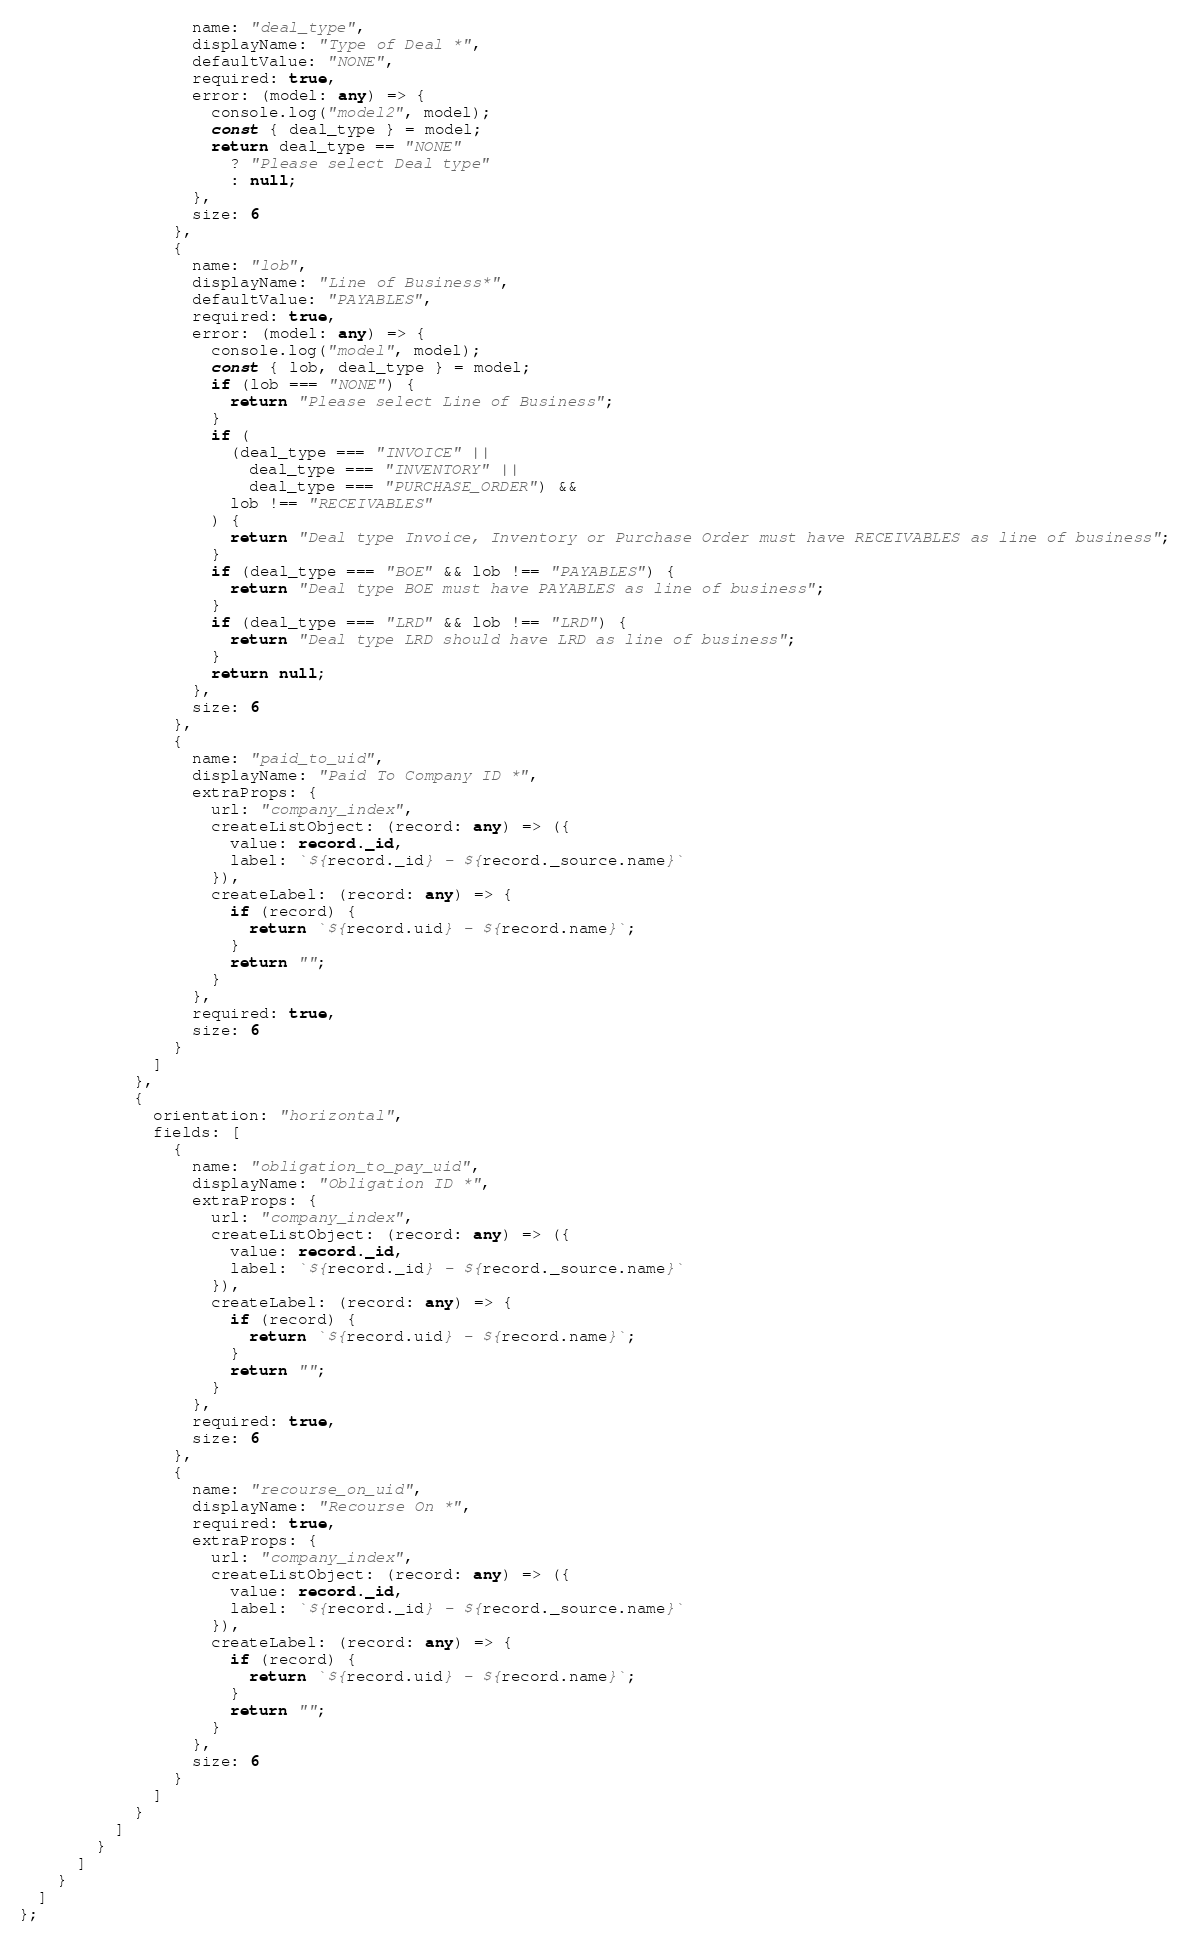Convert code to text. <code><loc_0><loc_0><loc_500><loc_500><_TypeScript_>                  name: "deal_type",
                  displayName: "Type of Deal *",
                  defaultValue: "NONE",
                  required: true,
                  error: (model: any) => {
                    console.log("model2", model);
                    const { deal_type } = model;
                    return deal_type == "NONE"
                      ? "Please select Deal type"
                      : null;
                  },
                  size: 6
                },
                {
                  name: "lob",
                  displayName: "Line of Business*",
                  defaultValue: "PAYABLES",
                  required: true,
                  error: (model: any) => {
                    console.log("model", model);
                    const { lob, deal_type } = model;
                    if (lob === "NONE") {
                      return "Please select Line of Business";
                    }
                    if (
                      (deal_type === "INVOICE" ||
                        deal_type === "INVENTORY" ||
                        deal_type === "PURCHASE_ORDER") &&
                      lob !== "RECEIVABLES"
                    ) {
                      return "Deal type Invoice, Inventory or Purchase Order must have RECEIVABLES as line of business";
                    }
                    if (deal_type === "BOE" && lob !== "PAYABLES") {
                      return "Deal type BOE must have PAYABLES as line of business";
                    }
                    if (deal_type === "LRD" && lob !== "LRD") {
                      return "Deal type LRD should have LRD as line of business";
                    }
                    return null;
                  },
                  size: 6
                },
                {
                  name: "paid_to_uid",
                  displayName: "Paid To Company ID *",
                  extraProps: {
                    url: "company_index",
                    createListObject: (record: any) => ({
                      value: record._id,
                      label: `${record._id} - ${record._source.name}`
                    }),
                    createLabel: (record: any) => {
                      if (record) {
                        return `${record.uid} - ${record.name}`;
                      }
                      return "";
                    }
                  },
                  required: true,
                  size: 6
                }
              ]
            },
            {
              orientation: "horizontal",
              fields: [
                {
                  name: "obligation_to_pay_uid",
                  displayName: "Obligation ID *",
                  extraProps: {
                    url: "company_index",
                    createListObject: (record: any) => ({
                      value: record._id,
                      label: `${record._id} - ${record._source.name}`
                    }),
                    createLabel: (record: any) => {
                      if (record) {
                        return `${record.uid} - ${record.name}`;
                      }
                      return "";
                    }
                  },
                  required: true,
                  size: 6
                },
                {
                  name: "recourse_on_uid",
                  displayName: "Recourse On *",
                  required: true,
                  extraProps: {
                    url: "company_index",
                    createListObject: (record: any) => ({
                      value: record._id,
                      label: `${record._id} - ${record._source.name}`
                    }),
                    createLabel: (record: any) => {
                      if (record) {
                        return `${record.uid} - ${record.name}`;
                      }
                      return "";
                    }
                  },
                  size: 6
                }
              ]
            }
          ]
        }
      ]
    }
  ]
};
</code> 